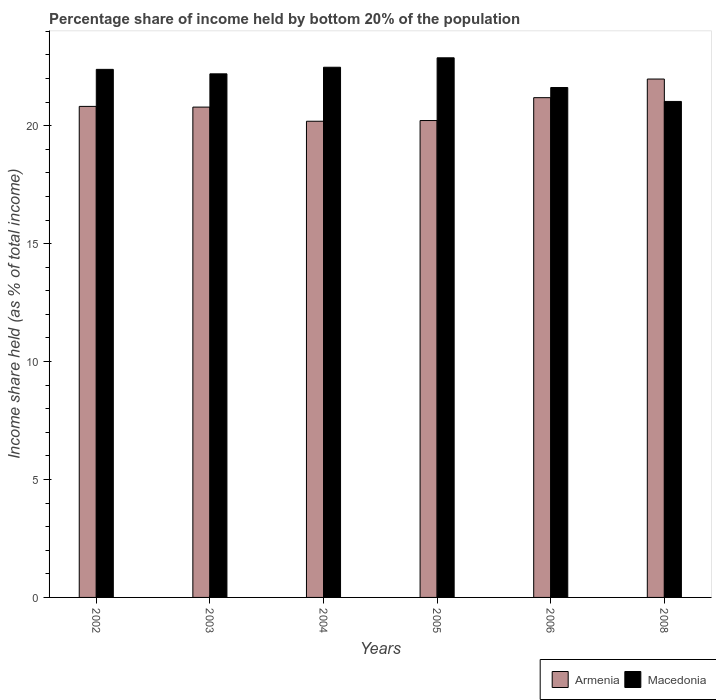Are the number of bars on each tick of the X-axis equal?
Give a very brief answer. Yes. How many bars are there on the 1st tick from the left?
Make the answer very short. 2. In how many cases, is the number of bars for a given year not equal to the number of legend labels?
Ensure brevity in your answer.  0. What is the share of income held by bottom 20% of the population in Macedonia in 2004?
Your answer should be compact. 22.48. Across all years, what is the maximum share of income held by bottom 20% of the population in Armenia?
Offer a very short reply. 21.98. Across all years, what is the minimum share of income held by bottom 20% of the population in Armenia?
Make the answer very short. 20.19. In which year was the share of income held by bottom 20% of the population in Macedonia maximum?
Provide a short and direct response. 2005. What is the total share of income held by bottom 20% of the population in Armenia in the graph?
Offer a terse response. 125.19. What is the difference between the share of income held by bottom 20% of the population in Armenia in 2005 and that in 2006?
Your answer should be very brief. -0.97. What is the difference between the share of income held by bottom 20% of the population in Macedonia in 2008 and the share of income held by bottom 20% of the population in Armenia in 2004?
Ensure brevity in your answer.  0.84. What is the average share of income held by bottom 20% of the population in Armenia per year?
Your answer should be compact. 20.86. In the year 2006, what is the difference between the share of income held by bottom 20% of the population in Macedonia and share of income held by bottom 20% of the population in Armenia?
Make the answer very short. 0.43. What is the ratio of the share of income held by bottom 20% of the population in Macedonia in 2004 to that in 2008?
Give a very brief answer. 1.07. What is the difference between the highest and the second highest share of income held by bottom 20% of the population in Macedonia?
Make the answer very short. 0.4. What is the difference between the highest and the lowest share of income held by bottom 20% of the population in Armenia?
Your response must be concise. 1.79. In how many years, is the share of income held by bottom 20% of the population in Armenia greater than the average share of income held by bottom 20% of the population in Armenia taken over all years?
Provide a succinct answer. 2. Is the sum of the share of income held by bottom 20% of the population in Armenia in 2002 and 2006 greater than the maximum share of income held by bottom 20% of the population in Macedonia across all years?
Offer a very short reply. Yes. What does the 2nd bar from the left in 2008 represents?
Your answer should be compact. Macedonia. What does the 1st bar from the right in 2003 represents?
Ensure brevity in your answer.  Macedonia. Are all the bars in the graph horizontal?
Offer a terse response. No. How many years are there in the graph?
Your answer should be compact. 6. What is the difference between two consecutive major ticks on the Y-axis?
Give a very brief answer. 5. Are the values on the major ticks of Y-axis written in scientific E-notation?
Your answer should be very brief. No. Where does the legend appear in the graph?
Your response must be concise. Bottom right. How many legend labels are there?
Ensure brevity in your answer.  2. How are the legend labels stacked?
Provide a short and direct response. Horizontal. What is the title of the graph?
Your answer should be compact. Percentage share of income held by bottom 20% of the population. Does "Kosovo" appear as one of the legend labels in the graph?
Make the answer very short. No. What is the label or title of the Y-axis?
Your answer should be compact. Income share held (as % of total income). What is the Income share held (as % of total income) in Armenia in 2002?
Provide a succinct answer. 20.82. What is the Income share held (as % of total income) of Macedonia in 2002?
Provide a short and direct response. 22.39. What is the Income share held (as % of total income) of Armenia in 2003?
Your response must be concise. 20.79. What is the Income share held (as % of total income) in Armenia in 2004?
Provide a short and direct response. 20.19. What is the Income share held (as % of total income) of Macedonia in 2004?
Keep it short and to the point. 22.48. What is the Income share held (as % of total income) of Armenia in 2005?
Your answer should be compact. 20.22. What is the Income share held (as % of total income) in Macedonia in 2005?
Your response must be concise. 22.88. What is the Income share held (as % of total income) of Armenia in 2006?
Offer a terse response. 21.19. What is the Income share held (as % of total income) of Macedonia in 2006?
Offer a very short reply. 21.62. What is the Income share held (as % of total income) in Armenia in 2008?
Your answer should be compact. 21.98. What is the Income share held (as % of total income) of Macedonia in 2008?
Your answer should be very brief. 21.03. Across all years, what is the maximum Income share held (as % of total income) of Armenia?
Offer a very short reply. 21.98. Across all years, what is the maximum Income share held (as % of total income) in Macedonia?
Offer a very short reply. 22.88. Across all years, what is the minimum Income share held (as % of total income) of Armenia?
Ensure brevity in your answer.  20.19. Across all years, what is the minimum Income share held (as % of total income) of Macedonia?
Provide a succinct answer. 21.03. What is the total Income share held (as % of total income) of Armenia in the graph?
Your answer should be compact. 125.19. What is the total Income share held (as % of total income) of Macedonia in the graph?
Give a very brief answer. 132.6. What is the difference between the Income share held (as % of total income) of Armenia in 2002 and that in 2003?
Your answer should be very brief. 0.03. What is the difference between the Income share held (as % of total income) of Macedonia in 2002 and that in 2003?
Offer a very short reply. 0.19. What is the difference between the Income share held (as % of total income) in Armenia in 2002 and that in 2004?
Give a very brief answer. 0.63. What is the difference between the Income share held (as % of total income) of Macedonia in 2002 and that in 2004?
Give a very brief answer. -0.09. What is the difference between the Income share held (as % of total income) in Macedonia in 2002 and that in 2005?
Your answer should be compact. -0.49. What is the difference between the Income share held (as % of total income) of Armenia in 2002 and that in 2006?
Keep it short and to the point. -0.37. What is the difference between the Income share held (as % of total income) in Macedonia in 2002 and that in 2006?
Offer a very short reply. 0.77. What is the difference between the Income share held (as % of total income) of Armenia in 2002 and that in 2008?
Ensure brevity in your answer.  -1.16. What is the difference between the Income share held (as % of total income) of Macedonia in 2002 and that in 2008?
Provide a succinct answer. 1.36. What is the difference between the Income share held (as % of total income) of Macedonia in 2003 and that in 2004?
Provide a succinct answer. -0.28. What is the difference between the Income share held (as % of total income) of Armenia in 2003 and that in 2005?
Ensure brevity in your answer.  0.57. What is the difference between the Income share held (as % of total income) of Macedonia in 2003 and that in 2005?
Offer a very short reply. -0.68. What is the difference between the Income share held (as % of total income) of Armenia in 2003 and that in 2006?
Give a very brief answer. -0.4. What is the difference between the Income share held (as % of total income) in Macedonia in 2003 and that in 2006?
Keep it short and to the point. 0.58. What is the difference between the Income share held (as % of total income) of Armenia in 2003 and that in 2008?
Your answer should be compact. -1.19. What is the difference between the Income share held (as % of total income) in Macedonia in 2003 and that in 2008?
Offer a very short reply. 1.17. What is the difference between the Income share held (as % of total income) of Armenia in 2004 and that in 2005?
Keep it short and to the point. -0.03. What is the difference between the Income share held (as % of total income) of Macedonia in 2004 and that in 2006?
Your answer should be very brief. 0.86. What is the difference between the Income share held (as % of total income) in Armenia in 2004 and that in 2008?
Ensure brevity in your answer.  -1.79. What is the difference between the Income share held (as % of total income) in Macedonia in 2004 and that in 2008?
Your answer should be very brief. 1.45. What is the difference between the Income share held (as % of total income) in Armenia in 2005 and that in 2006?
Offer a very short reply. -0.97. What is the difference between the Income share held (as % of total income) in Macedonia in 2005 and that in 2006?
Give a very brief answer. 1.26. What is the difference between the Income share held (as % of total income) in Armenia in 2005 and that in 2008?
Provide a succinct answer. -1.76. What is the difference between the Income share held (as % of total income) of Macedonia in 2005 and that in 2008?
Keep it short and to the point. 1.85. What is the difference between the Income share held (as % of total income) of Armenia in 2006 and that in 2008?
Provide a short and direct response. -0.79. What is the difference between the Income share held (as % of total income) of Macedonia in 2006 and that in 2008?
Provide a short and direct response. 0.59. What is the difference between the Income share held (as % of total income) in Armenia in 2002 and the Income share held (as % of total income) in Macedonia in 2003?
Offer a very short reply. -1.38. What is the difference between the Income share held (as % of total income) of Armenia in 2002 and the Income share held (as % of total income) of Macedonia in 2004?
Your response must be concise. -1.66. What is the difference between the Income share held (as % of total income) in Armenia in 2002 and the Income share held (as % of total income) in Macedonia in 2005?
Offer a very short reply. -2.06. What is the difference between the Income share held (as % of total income) in Armenia in 2002 and the Income share held (as % of total income) in Macedonia in 2006?
Provide a short and direct response. -0.8. What is the difference between the Income share held (as % of total income) of Armenia in 2002 and the Income share held (as % of total income) of Macedonia in 2008?
Offer a terse response. -0.21. What is the difference between the Income share held (as % of total income) in Armenia in 2003 and the Income share held (as % of total income) in Macedonia in 2004?
Your answer should be very brief. -1.69. What is the difference between the Income share held (as % of total income) of Armenia in 2003 and the Income share held (as % of total income) of Macedonia in 2005?
Ensure brevity in your answer.  -2.09. What is the difference between the Income share held (as % of total income) of Armenia in 2003 and the Income share held (as % of total income) of Macedonia in 2006?
Ensure brevity in your answer.  -0.83. What is the difference between the Income share held (as % of total income) in Armenia in 2003 and the Income share held (as % of total income) in Macedonia in 2008?
Keep it short and to the point. -0.24. What is the difference between the Income share held (as % of total income) in Armenia in 2004 and the Income share held (as % of total income) in Macedonia in 2005?
Provide a succinct answer. -2.69. What is the difference between the Income share held (as % of total income) in Armenia in 2004 and the Income share held (as % of total income) in Macedonia in 2006?
Offer a very short reply. -1.43. What is the difference between the Income share held (as % of total income) of Armenia in 2004 and the Income share held (as % of total income) of Macedonia in 2008?
Your answer should be very brief. -0.84. What is the difference between the Income share held (as % of total income) of Armenia in 2005 and the Income share held (as % of total income) of Macedonia in 2008?
Provide a short and direct response. -0.81. What is the difference between the Income share held (as % of total income) of Armenia in 2006 and the Income share held (as % of total income) of Macedonia in 2008?
Your response must be concise. 0.16. What is the average Income share held (as % of total income) in Armenia per year?
Give a very brief answer. 20.86. What is the average Income share held (as % of total income) in Macedonia per year?
Make the answer very short. 22.1. In the year 2002, what is the difference between the Income share held (as % of total income) in Armenia and Income share held (as % of total income) in Macedonia?
Provide a succinct answer. -1.57. In the year 2003, what is the difference between the Income share held (as % of total income) in Armenia and Income share held (as % of total income) in Macedonia?
Give a very brief answer. -1.41. In the year 2004, what is the difference between the Income share held (as % of total income) in Armenia and Income share held (as % of total income) in Macedonia?
Provide a succinct answer. -2.29. In the year 2005, what is the difference between the Income share held (as % of total income) in Armenia and Income share held (as % of total income) in Macedonia?
Your answer should be compact. -2.66. In the year 2006, what is the difference between the Income share held (as % of total income) in Armenia and Income share held (as % of total income) in Macedonia?
Provide a succinct answer. -0.43. In the year 2008, what is the difference between the Income share held (as % of total income) in Armenia and Income share held (as % of total income) in Macedonia?
Your answer should be very brief. 0.95. What is the ratio of the Income share held (as % of total income) in Armenia in 2002 to that in 2003?
Provide a short and direct response. 1. What is the ratio of the Income share held (as % of total income) in Macedonia in 2002 to that in 2003?
Provide a succinct answer. 1.01. What is the ratio of the Income share held (as % of total income) in Armenia in 2002 to that in 2004?
Your response must be concise. 1.03. What is the ratio of the Income share held (as % of total income) of Macedonia in 2002 to that in 2004?
Keep it short and to the point. 1. What is the ratio of the Income share held (as % of total income) in Armenia in 2002 to that in 2005?
Offer a terse response. 1.03. What is the ratio of the Income share held (as % of total income) of Macedonia in 2002 to that in 2005?
Offer a terse response. 0.98. What is the ratio of the Income share held (as % of total income) in Armenia in 2002 to that in 2006?
Provide a succinct answer. 0.98. What is the ratio of the Income share held (as % of total income) of Macedonia in 2002 to that in 2006?
Offer a terse response. 1.04. What is the ratio of the Income share held (as % of total income) of Armenia in 2002 to that in 2008?
Your response must be concise. 0.95. What is the ratio of the Income share held (as % of total income) of Macedonia in 2002 to that in 2008?
Provide a succinct answer. 1.06. What is the ratio of the Income share held (as % of total income) of Armenia in 2003 to that in 2004?
Keep it short and to the point. 1.03. What is the ratio of the Income share held (as % of total income) in Macedonia in 2003 to that in 2004?
Offer a terse response. 0.99. What is the ratio of the Income share held (as % of total income) of Armenia in 2003 to that in 2005?
Offer a terse response. 1.03. What is the ratio of the Income share held (as % of total income) of Macedonia in 2003 to that in 2005?
Your answer should be compact. 0.97. What is the ratio of the Income share held (as % of total income) of Armenia in 2003 to that in 2006?
Make the answer very short. 0.98. What is the ratio of the Income share held (as % of total income) in Macedonia in 2003 to that in 2006?
Provide a short and direct response. 1.03. What is the ratio of the Income share held (as % of total income) of Armenia in 2003 to that in 2008?
Provide a short and direct response. 0.95. What is the ratio of the Income share held (as % of total income) of Macedonia in 2003 to that in 2008?
Ensure brevity in your answer.  1.06. What is the ratio of the Income share held (as % of total income) in Macedonia in 2004 to that in 2005?
Give a very brief answer. 0.98. What is the ratio of the Income share held (as % of total income) in Armenia in 2004 to that in 2006?
Provide a short and direct response. 0.95. What is the ratio of the Income share held (as % of total income) in Macedonia in 2004 to that in 2006?
Offer a very short reply. 1.04. What is the ratio of the Income share held (as % of total income) in Armenia in 2004 to that in 2008?
Give a very brief answer. 0.92. What is the ratio of the Income share held (as % of total income) in Macedonia in 2004 to that in 2008?
Your response must be concise. 1.07. What is the ratio of the Income share held (as % of total income) in Armenia in 2005 to that in 2006?
Ensure brevity in your answer.  0.95. What is the ratio of the Income share held (as % of total income) in Macedonia in 2005 to that in 2006?
Offer a very short reply. 1.06. What is the ratio of the Income share held (as % of total income) in Armenia in 2005 to that in 2008?
Give a very brief answer. 0.92. What is the ratio of the Income share held (as % of total income) in Macedonia in 2005 to that in 2008?
Your response must be concise. 1.09. What is the ratio of the Income share held (as % of total income) of Armenia in 2006 to that in 2008?
Offer a terse response. 0.96. What is the ratio of the Income share held (as % of total income) in Macedonia in 2006 to that in 2008?
Provide a short and direct response. 1.03. What is the difference between the highest and the second highest Income share held (as % of total income) in Armenia?
Give a very brief answer. 0.79. What is the difference between the highest and the lowest Income share held (as % of total income) in Armenia?
Make the answer very short. 1.79. What is the difference between the highest and the lowest Income share held (as % of total income) of Macedonia?
Ensure brevity in your answer.  1.85. 